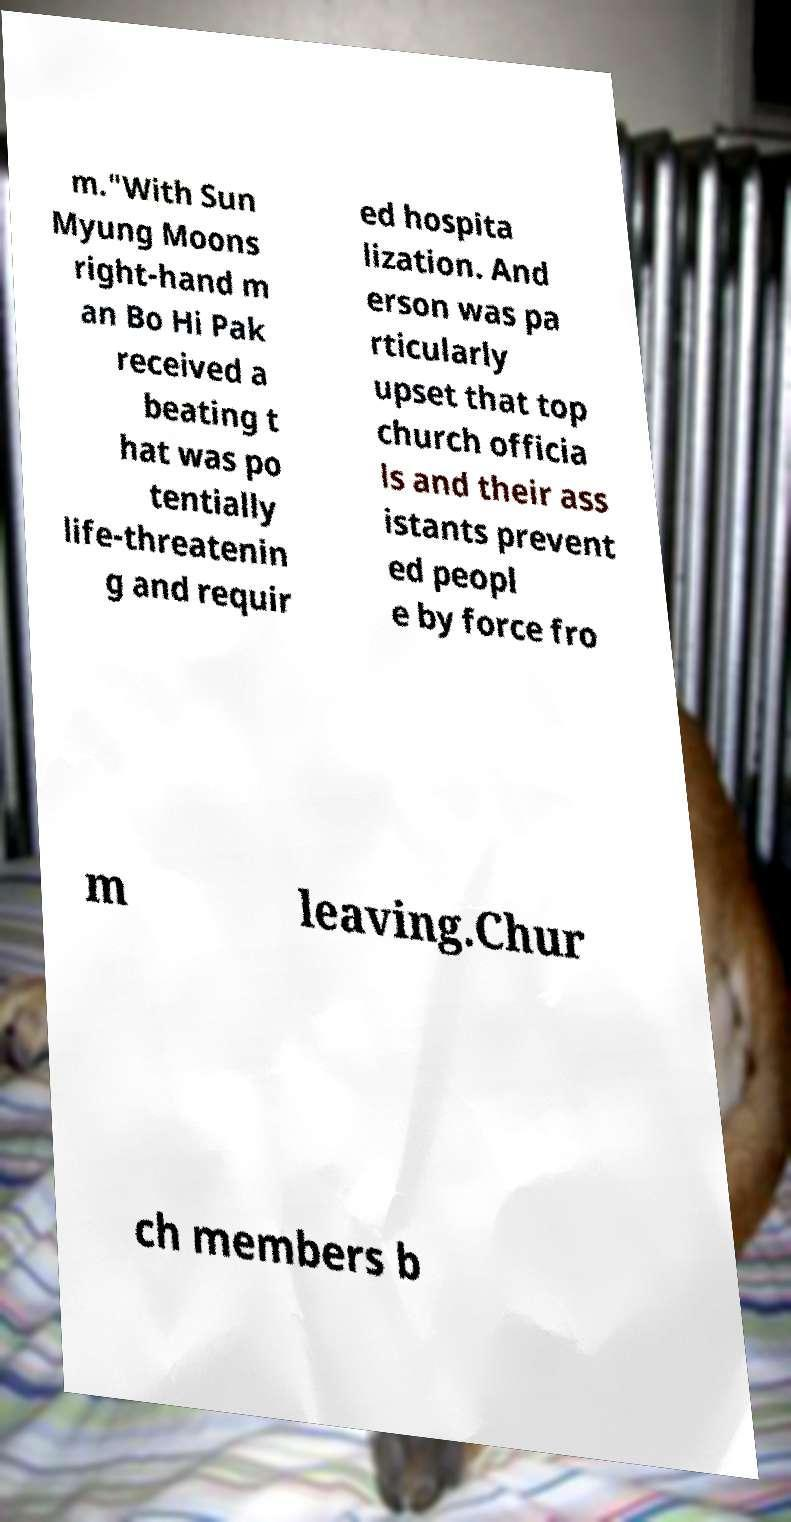Can you accurately transcribe the text from the provided image for me? m."With Sun Myung Moons right-hand m an Bo Hi Pak received a beating t hat was po tentially life-threatenin g and requir ed hospita lization. And erson was pa rticularly upset that top church officia ls and their ass istants prevent ed peopl e by force fro m leaving.Chur ch members b 